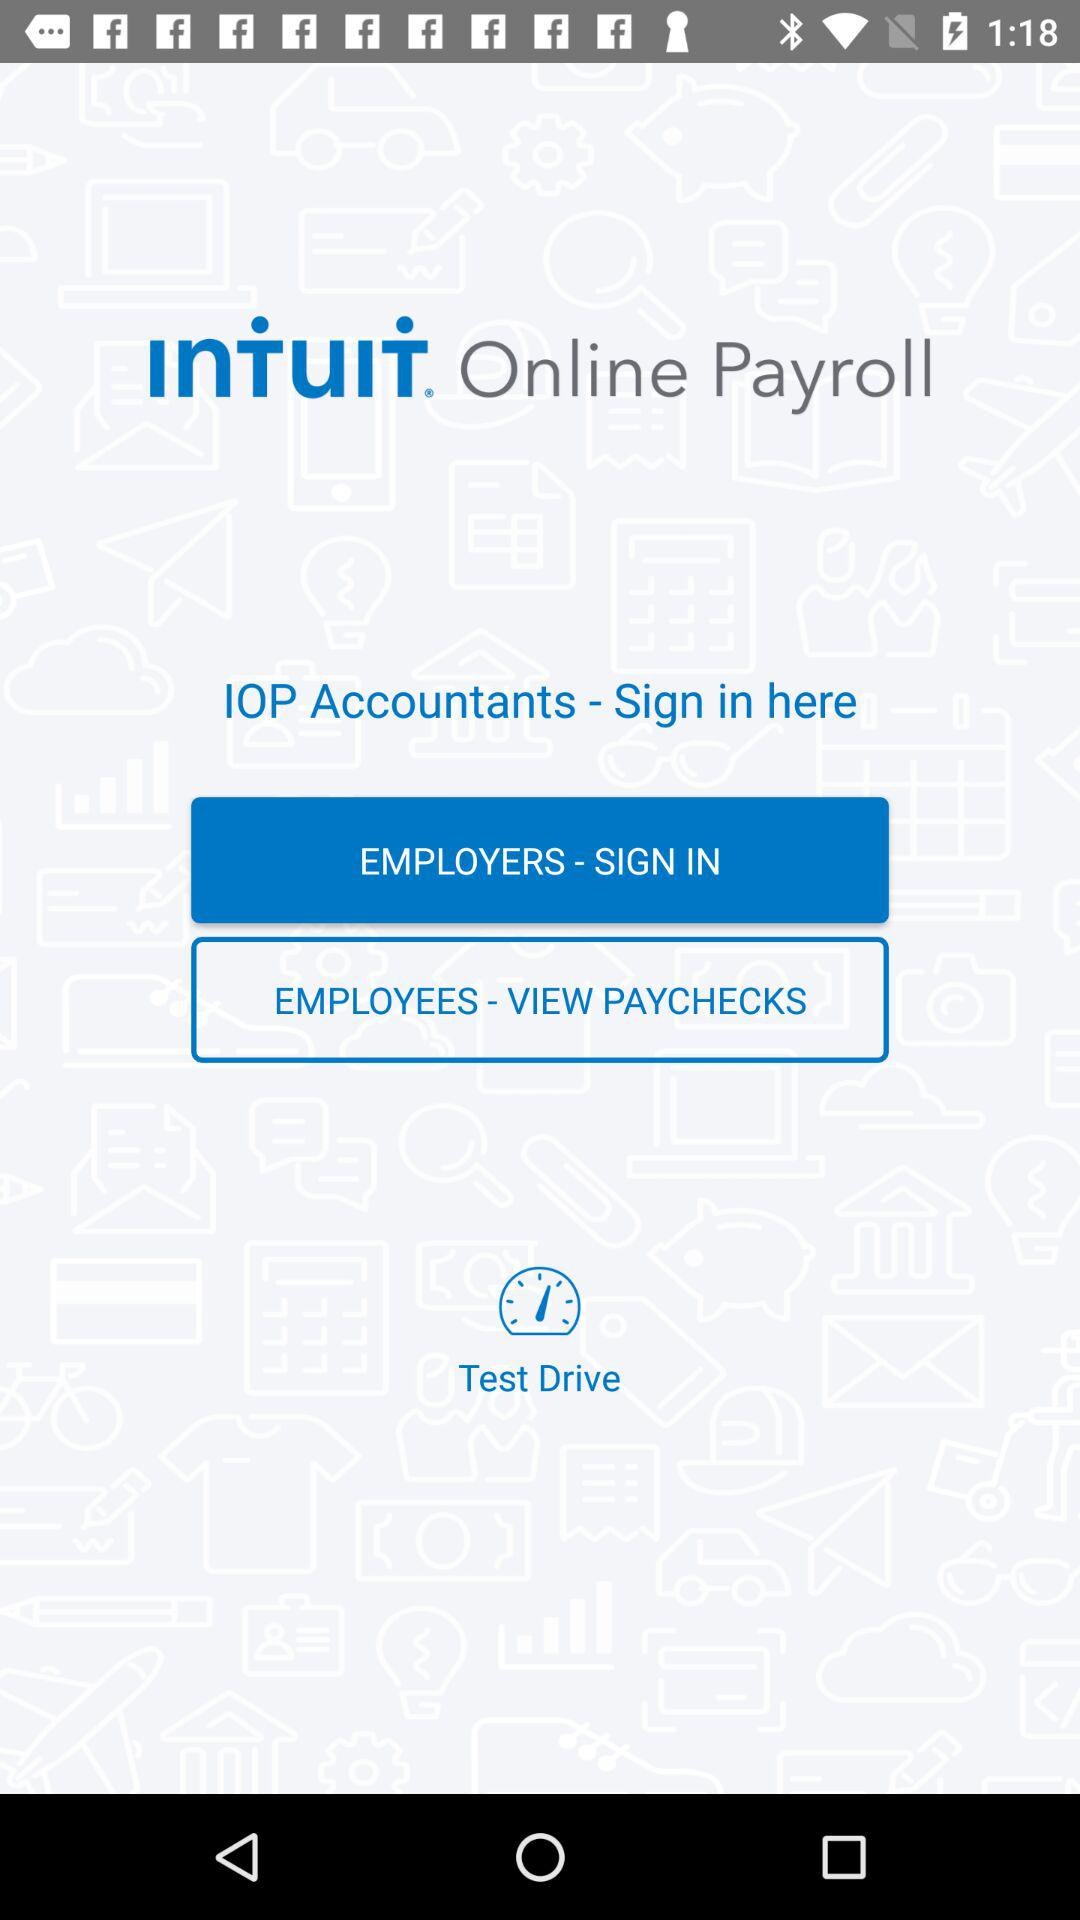What is the application name? The application name is "INTUIT". 